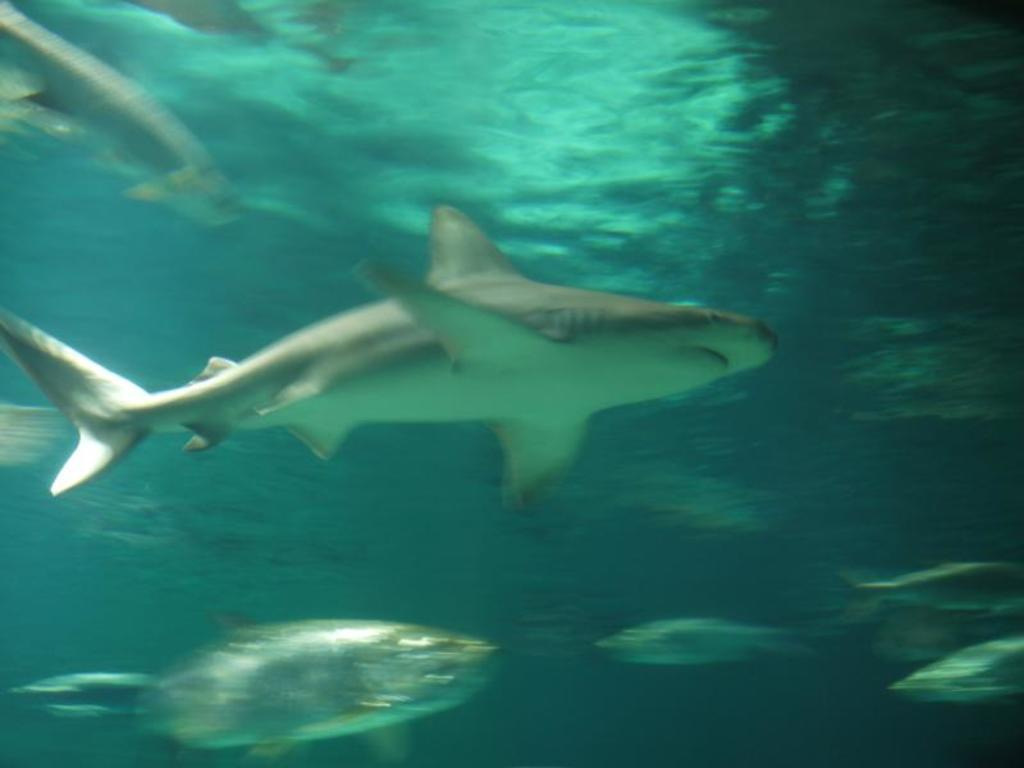What type of animals can be seen in the image? There are fishes in the image. Where are the fishes located? The fishes are inside the water. What is the color of the water in the image? The water is in green color. What type of stamp can be seen on the fishes' apparel in the image? There is no stamp or apparel present on the fishes in the image, as they are simply swimming in the water. 